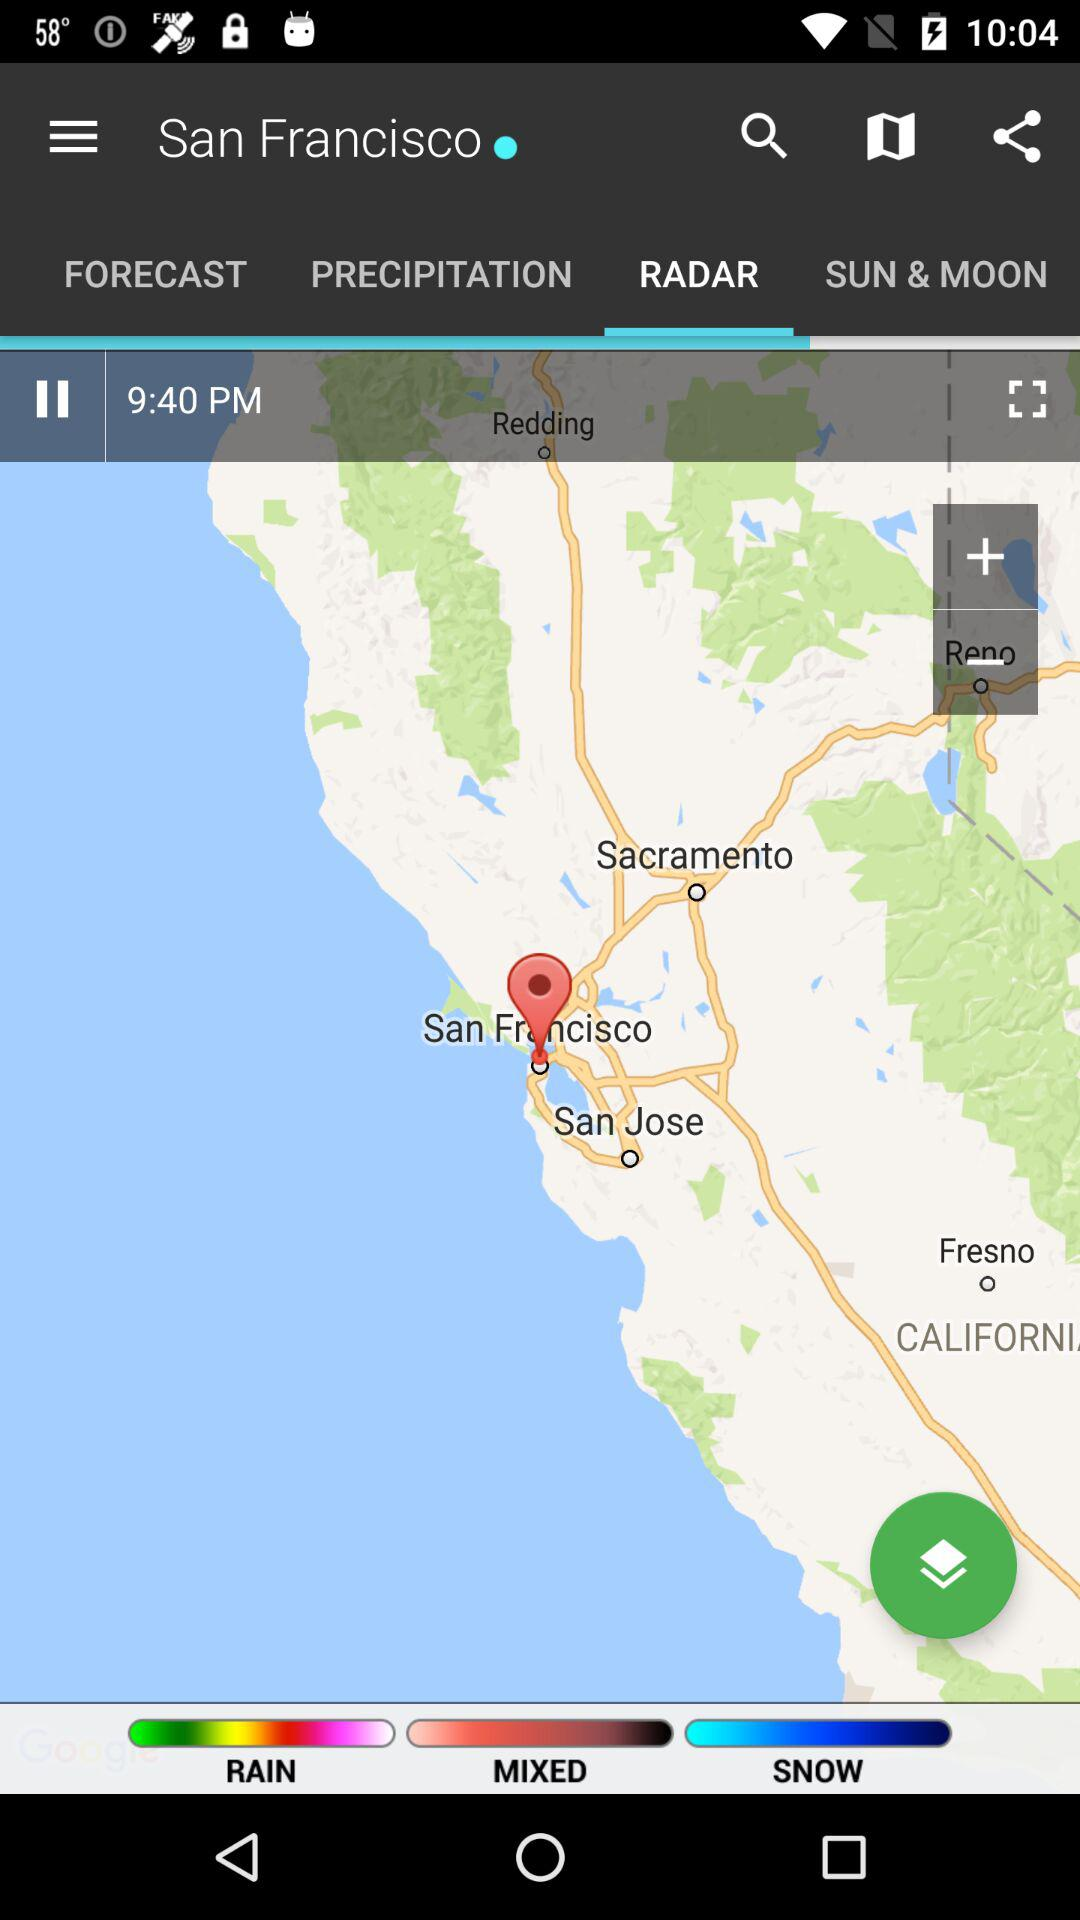What is the given time? The given time is 9:40 PM. 